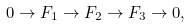Convert formula to latex. <formula><loc_0><loc_0><loc_500><loc_500>0 \rightarrow F _ { 1 } \rightarrow F _ { 2 } \rightarrow F _ { 3 } \rightarrow 0 ,</formula> 